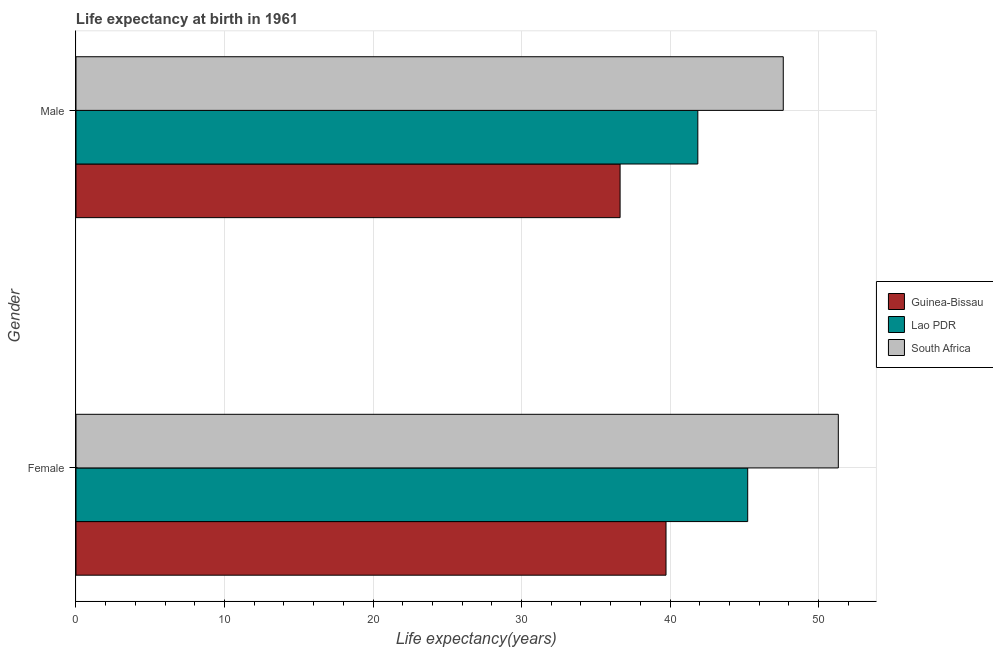Are the number of bars per tick equal to the number of legend labels?
Provide a short and direct response. Yes. What is the label of the 2nd group of bars from the top?
Ensure brevity in your answer.  Female. What is the life expectancy(female) in Lao PDR?
Provide a short and direct response. 45.23. Across all countries, what is the maximum life expectancy(female)?
Keep it short and to the point. 51.33. Across all countries, what is the minimum life expectancy(male)?
Provide a succinct answer. 36.63. In which country was the life expectancy(female) maximum?
Your response must be concise. South Africa. In which country was the life expectancy(female) minimum?
Provide a short and direct response. Guinea-Bissau. What is the total life expectancy(male) in the graph?
Your answer should be very brief. 126.13. What is the difference between the life expectancy(female) in Guinea-Bissau and that in Lao PDR?
Make the answer very short. -5.5. What is the difference between the life expectancy(male) in South Africa and the life expectancy(female) in Guinea-Bissau?
Your answer should be compact. 7.9. What is the average life expectancy(female) per country?
Your response must be concise. 45.43. What is the difference between the life expectancy(male) and life expectancy(female) in South Africa?
Give a very brief answer. -3.71. What is the ratio of the life expectancy(female) in Guinea-Bissau to that in Lao PDR?
Your answer should be compact. 0.88. In how many countries, is the life expectancy(male) greater than the average life expectancy(male) taken over all countries?
Provide a short and direct response. 1. What does the 3rd bar from the top in Female represents?
Make the answer very short. Guinea-Bissau. What does the 3rd bar from the bottom in Female represents?
Ensure brevity in your answer.  South Africa. How many bars are there?
Make the answer very short. 6. Are all the bars in the graph horizontal?
Your response must be concise. Yes. Does the graph contain any zero values?
Keep it short and to the point. No. How many legend labels are there?
Your response must be concise. 3. How are the legend labels stacked?
Give a very brief answer. Vertical. What is the title of the graph?
Keep it short and to the point. Life expectancy at birth in 1961. What is the label or title of the X-axis?
Keep it short and to the point. Life expectancy(years). What is the Life expectancy(years) in Guinea-Bissau in Female?
Offer a terse response. 39.73. What is the Life expectancy(years) of Lao PDR in Female?
Provide a short and direct response. 45.23. What is the Life expectancy(years) of South Africa in Female?
Offer a terse response. 51.33. What is the Life expectancy(years) in Guinea-Bissau in Male?
Your answer should be compact. 36.63. What is the Life expectancy(years) of Lao PDR in Male?
Give a very brief answer. 41.87. What is the Life expectancy(years) in South Africa in Male?
Ensure brevity in your answer.  47.62. Across all Gender, what is the maximum Life expectancy(years) in Guinea-Bissau?
Your response must be concise. 39.73. Across all Gender, what is the maximum Life expectancy(years) in Lao PDR?
Offer a very short reply. 45.23. Across all Gender, what is the maximum Life expectancy(years) in South Africa?
Give a very brief answer. 51.33. Across all Gender, what is the minimum Life expectancy(years) of Guinea-Bissau?
Offer a very short reply. 36.63. Across all Gender, what is the minimum Life expectancy(years) of Lao PDR?
Make the answer very short. 41.87. Across all Gender, what is the minimum Life expectancy(years) of South Africa?
Your answer should be very brief. 47.62. What is the total Life expectancy(years) in Guinea-Bissau in the graph?
Give a very brief answer. 76.36. What is the total Life expectancy(years) in Lao PDR in the graph?
Offer a very short reply. 87.1. What is the total Life expectancy(years) in South Africa in the graph?
Provide a short and direct response. 98.95. What is the difference between the Life expectancy(years) of Guinea-Bissau in Female and that in Male?
Provide a succinct answer. 3.09. What is the difference between the Life expectancy(years) of Lao PDR in Female and that in Male?
Provide a succinct answer. 3.36. What is the difference between the Life expectancy(years) in South Africa in Female and that in Male?
Keep it short and to the point. 3.71. What is the difference between the Life expectancy(years) of Guinea-Bissau in Female and the Life expectancy(years) of Lao PDR in Male?
Your answer should be compact. -2.14. What is the difference between the Life expectancy(years) in Guinea-Bissau in Female and the Life expectancy(years) in South Africa in Male?
Your answer should be very brief. -7.89. What is the difference between the Life expectancy(years) in Lao PDR in Female and the Life expectancy(years) in South Africa in Male?
Make the answer very short. -2.4. What is the average Life expectancy(years) in Guinea-Bissau per Gender?
Your response must be concise. 38.18. What is the average Life expectancy(years) in Lao PDR per Gender?
Provide a short and direct response. 43.55. What is the average Life expectancy(years) of South Africa per Gender?
Offer a terse response. 49.48. What is the difference between the Life expectancy(years) in Guinea-Bissau and Life expectancy(years) in Lao PDR in Female?
Ensure brevity in your answer.  -5.5. What is the difference between the Life expectancy(years) of Guinea-Bissau and Life expectancy(years) of South Africa in Female?
Provide a succinct answer. -11.6. What is the difference between the Life expectancy(years) in Lao PDR and Life expectancy(years) in South Africa in Female?
Offer a very short reply. -6.1. What is the difference between the Life expectancy(years) of Guinea-Bissau and Life expectancy(years) of Lao PDR in Male?
Make the answer very short. -5.23. What is the difference between the Life expectancy(years) in Guinea-Bissau and Life expectancy(years) in South Africa in Male?
Keep it short and to the point. -10.99. What is the difference between the Life expectancy(years) in Lao PDR and Life expectancy(years) in South Africa in Male?
Offer a very short reply. -5.75. What is the ratio of the Life expectancy(years) in Guinea-Bissau in Female to that in Male?
Your answer should be very brief. 1.08. What is the ratio of the Life expectancy(years) of Lao PDR in Female to that in Male?
Your answer should be compact. 1.08. What is the ratio of the Life expectancy(years) of South Africa in Female to that in Male?
Make the answer very short. 1.08. What is the difference between the highest and the second highest Life expectancy(years) in Guinea-Bissau?
Your response must be concise. 3.09. What is the difference between the highest and the second highest Life expectancy(years) of Lao PDR?
Make the answer very short. 3.36. What is the difference between the highest and the second highest Life expectancy(years) of South Africa?
Your answer should be compact. 3.71. What is the difference between the highest and the lowest Life expectancy(years) of Guinea-Bissau?
Offer a very short reply. 3.09. What is the difference between the highest and the lowest Life expectancy(years) of Lao PDR?
Provide a succinct answer. 3.36. What is the difference between the highest and the lowest Life expectancy(years) in South Africa?
Your response must be concise. 3.71. 